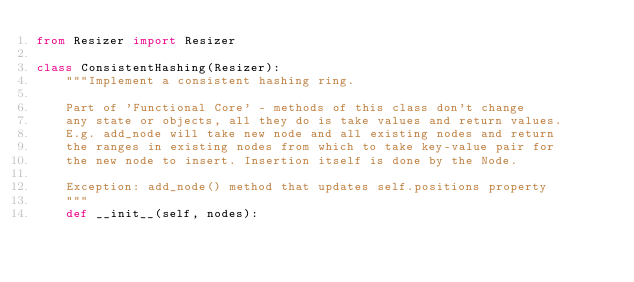Convert code to text. <code><loc_0><loc_0><loc_500><loc_500><_Python_>from Resizer import Resizer

class ConsistentHashing(Resizer):
    """Implement a consistent hashing ring.

    Part of 'Functional Core' - methods of this class don't change
    any state or objects, all they do is take values and return values.
    E.g. add_node will take new node and all existing nodes and return
    the ranges in existing nodes from which to take key-value pair for
    the new node to insert. Insertion itself is done by the Node.

    Exception: add_node() method that updates self.positions property
    """
    def __init__(self, nodes):</code> 